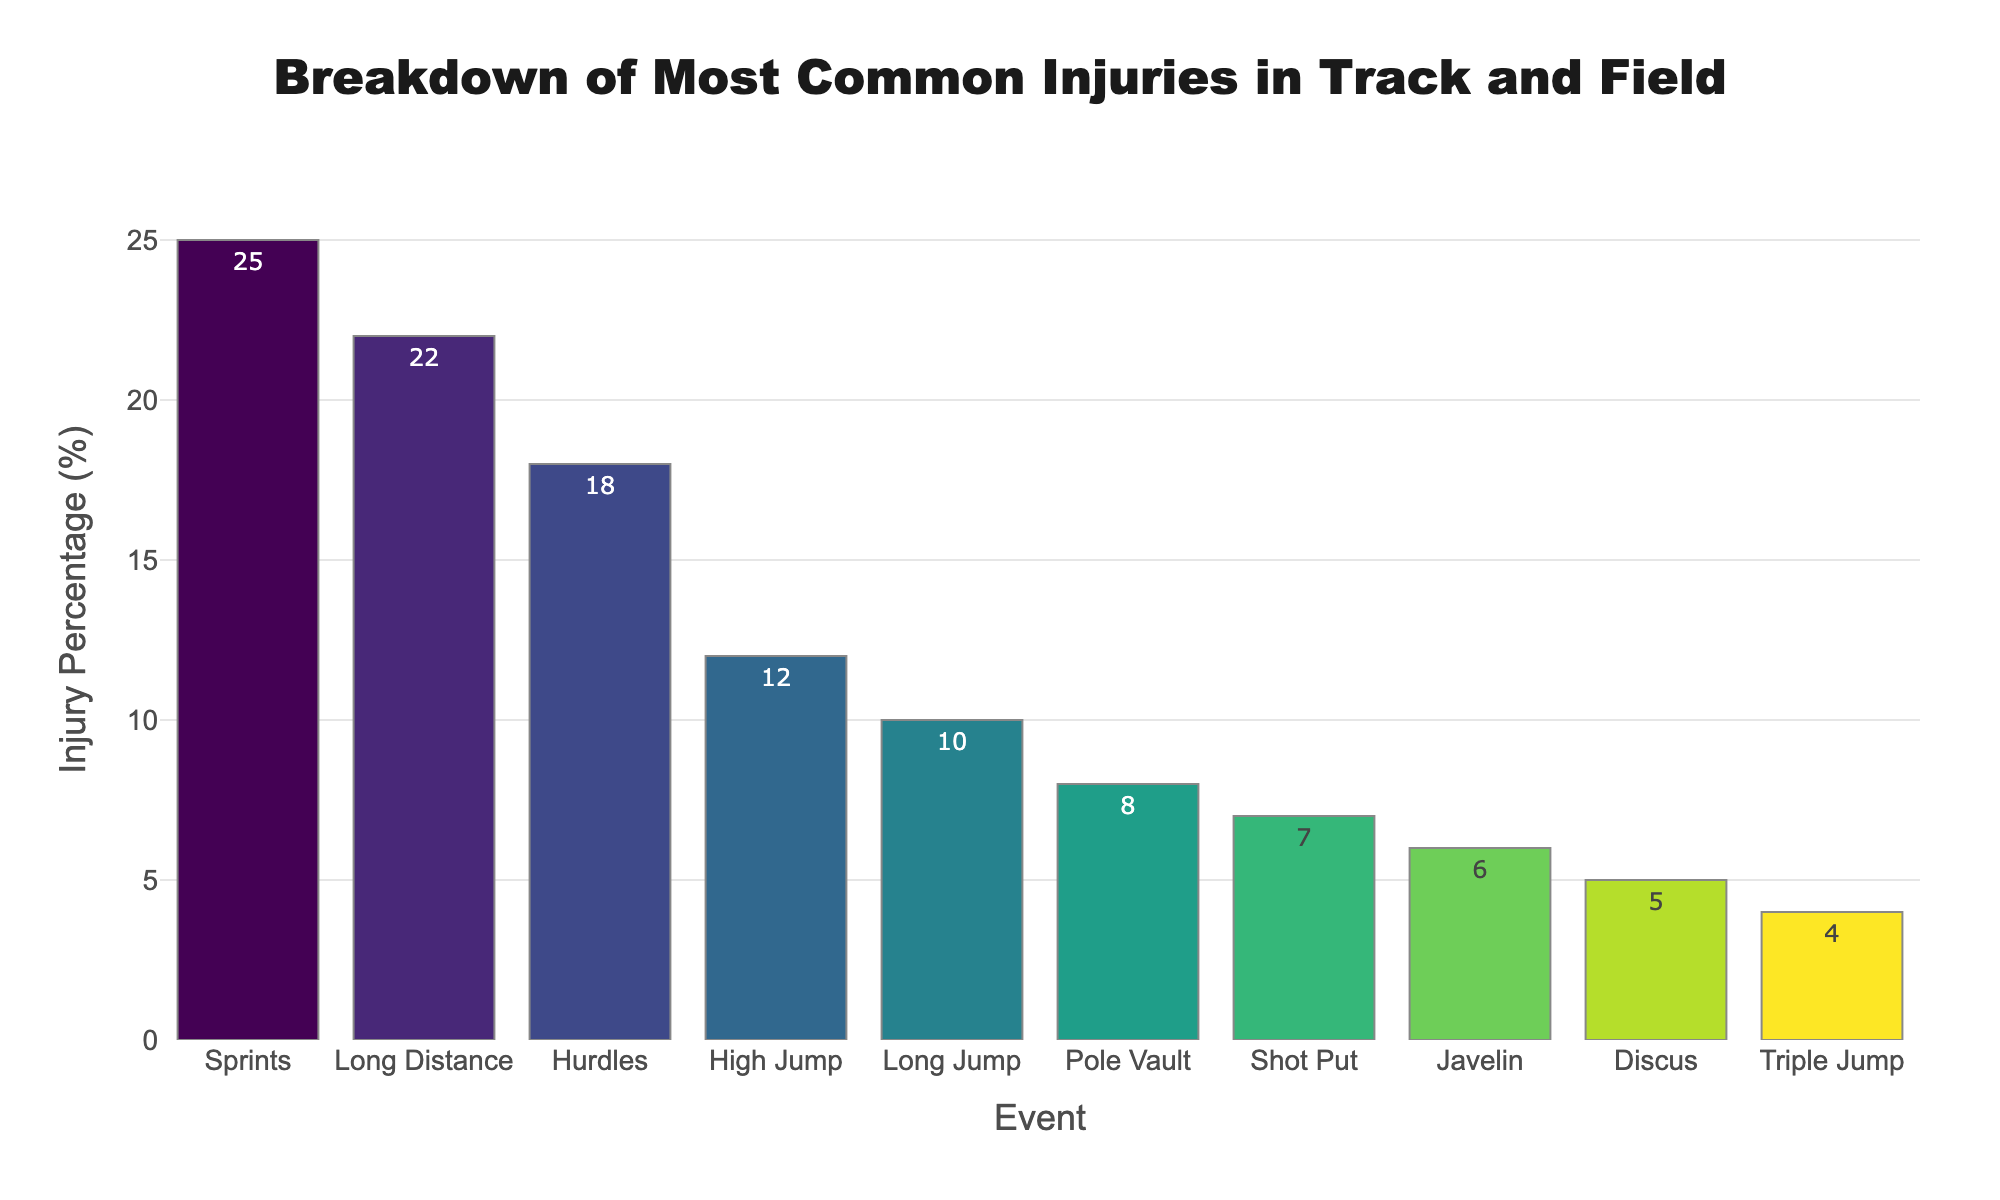What event has the highest injury percentage? Look at the bar chart and identify the tallest bar, which corresponds to the event with the highest injury percentage. The event is Sprints with 25%.
Answer: Sprints Which events have an injury percentage of less than 10%? Inspect the bars in the chart to see which ones are shorter than the 10% mark on the y-axis. The events are Pole Vault, Shot Put, Javelin, Discus, and Triple Jump.
Answer: Pole Vault, Shot Put, Javelin, Discus, Triple Jump How much higher is the injury percentage for Sprints compared to Long Distance running? Find the injury percentages for Sprints and Long Distance running (25% and 22%, respectively). Subtract the latter from the former: 25% - 22% = 3%.
Answer: 3% What’s the combined injury percentage for High Jump and Long Jump? Sum the injury percentages of High Jump (12%) and Long Jump (10%): 12% + 10% = 22%.
Answer: 22% How does the injury percentage for Hurdles compare to that for Pole Vault? Find the injury percentages for Hurdles and Pole Vault (18% and 8%, respectively). Subtract the latter from the former: 18% - 8% = 10%.
Answer: 10% Which event has the second highest injury percentage? Locate the second tallest bar in the chart, which corresponds to Long Distance running with 22%.
Answer: Long Distance running Is the injury percentage for Shot Put greater than that for Javelin? Compare the heights of the bars for Shot Put and Javelin. Shot Put has 7% and Javelin has 6%, so Shot Put has a higher injury percentage.
Answer: Yes How many events have an injury percentage less than or equal to 10%? Count the bars that reach the 10% mark or below. The events are Long Jump, Pole Vault, Shot Put, Javelin, Discus, and Triple Jump; thus, there are 6 events.
Answer: 6 What is the average injury percentage of the top three events? Identify the top three events with the highest injury percentages: Sprints (25%), Long Distance (22%), and Hurdles (18%). Sum these percentages: 25% + 22% + 18% = 65%, then divide by 3: 65/3 ≈ 21.67%.
Answer: 21.67% Which event has the shortest bar in the chart? The shortest bar in the chart represents Triple Jump with an injury percentage of 4%.
Answer: Triple Jump 